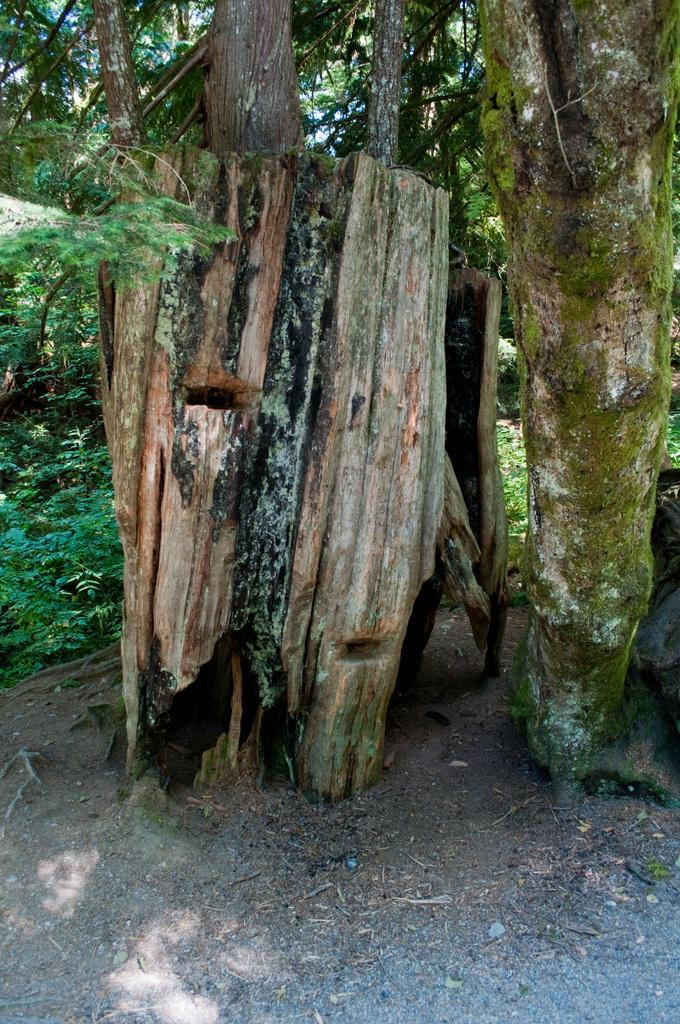What type of wooden object is present in the image? There is a wooden object in the image, but its specific type cannot be determined from the provided facts. What type of vegetation is visible in the image? There are many trees in the image. What part of the natural environment is visible in the image? The sky is visible in the image. What type of horn can be seen on the wooden object in the image? There is no horn present on the wooden object in the image. What is the development stage of the mouth visible on the wooden object in the image? There is no mouth present on the wooden object in the image. 